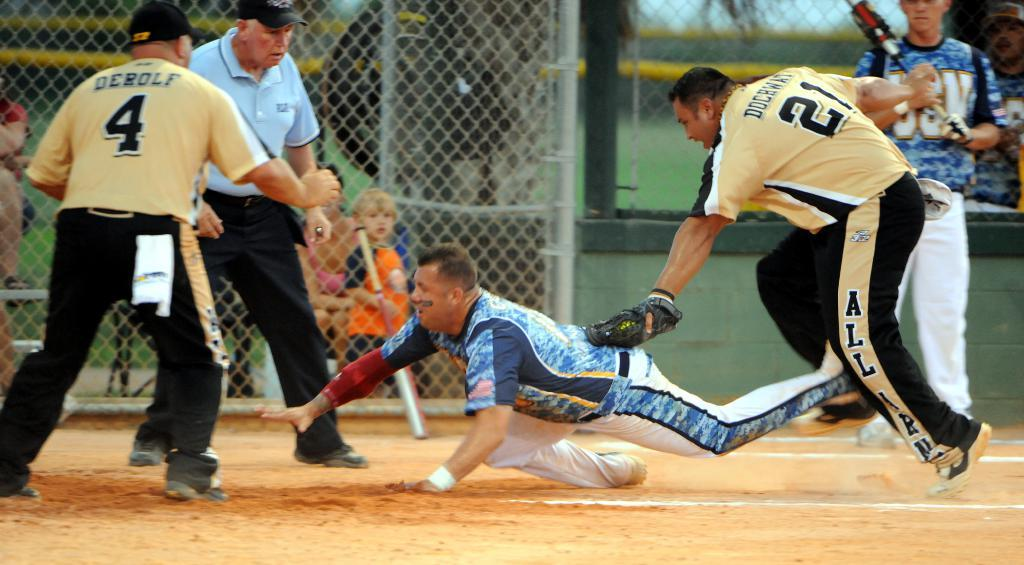<image>
Provide a brief description of the given image. A baseball player wearing the number 21 on the back of his jersey is attempting to get another player out before he finishes sliding on to a base. 